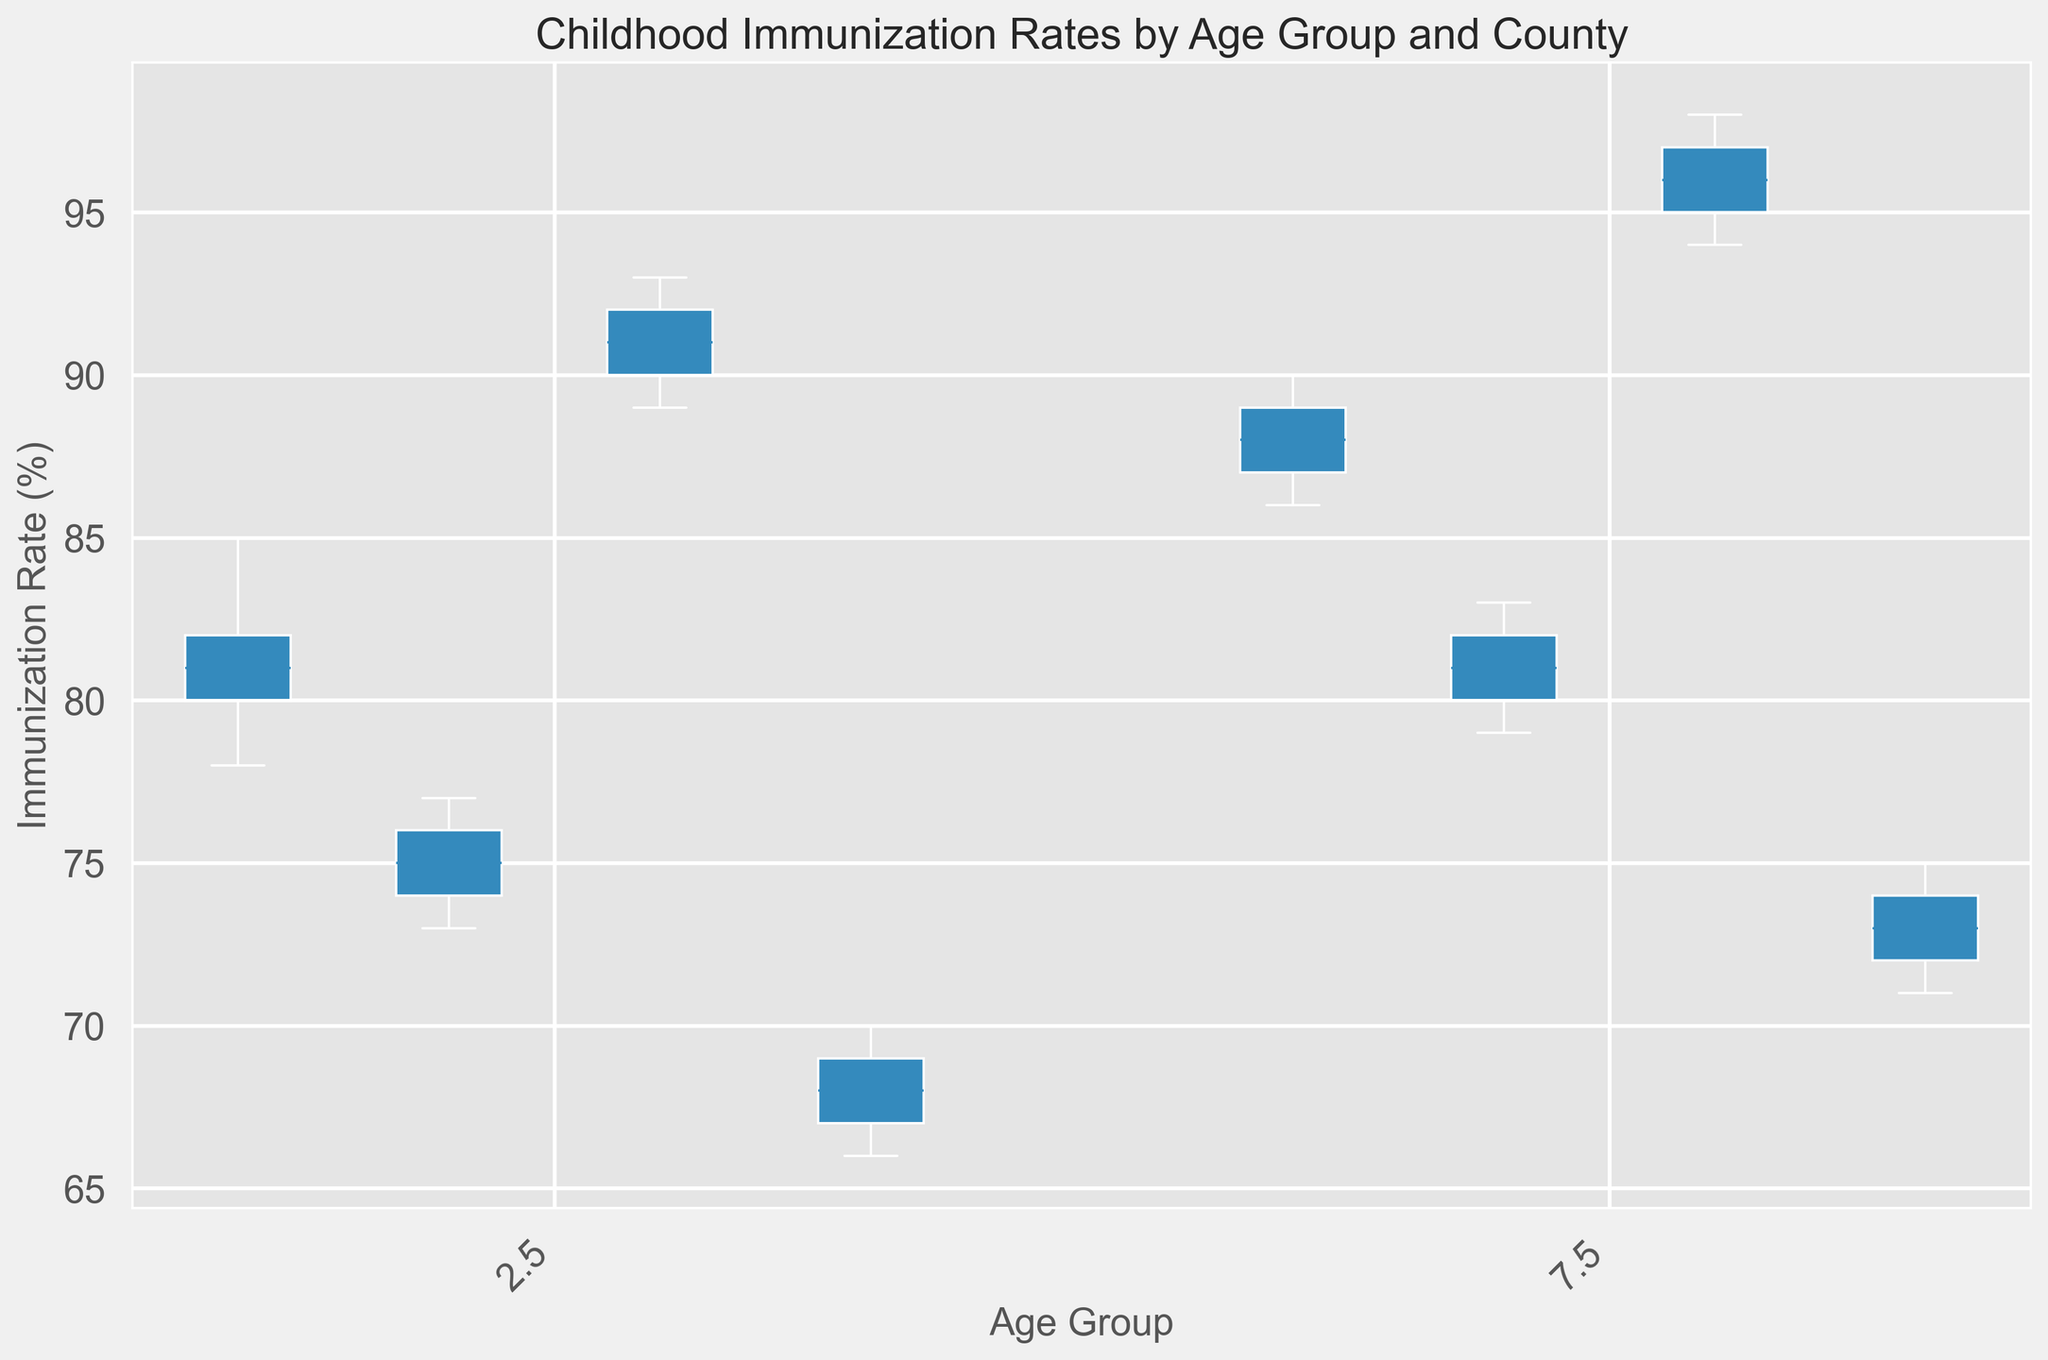Which county has the highest median immunization rate for the 0-1 age group? To find the highest median immunization rate for the 0-1 age group, look at the center lines of the boxplots representing each county. Based on the boxplot, County C has the highest median immunization rate for the 0-1 age group.
Answer: County C Which age group shows greater variability in immunization rates in County A? To determine which age group has greater variability, compare the lengths of the boxes and whiskers for each age group in County A. The 1-2 age group in County A has longer whiskers compared to the other, indicating greater variability.
Answer: 1-2 Is the immunization rate for the 1-2 age group in County D generally lower or higher than the 0-1 age group in County C? To compare these two groups, look at the position of the boxplots. The boxplots for the 1-2 age group in County D are generally positioned lower on the y-axis than those for the 0-1 age group in County C, indicating that the rates are generally lower in County D.
Answer: Lower What is the range of immunization rates for the 0-1 age group in County D? To find the range, look at the bottom and top whiskers of the boxplot for the 0-1 age group in County D. The range is from the lowest value at 66 to the highest value at 70. The range is calculated as 70 - 66.
Answer: 4 Which county has the smallest interquartile range (IQR) for the 1-2 age group? To identify the smallest IQR, compare the lengths of the boxes for each county within the 1-2 age group. The IQR is from Q1 to Q3. County C has the smallest length of the box, indicating the smallest IQR.
Answer: County C Is there a notable outlier in any county within the 0-1 age group? To find outliers, look for any points plotted outside the whiskers of the boxplots for the 0-1 age group. The boxplots do not show any points outside the whiskers, so there are no notable outliers.
Answer: No Are the immunization rates in County B more consistent in the 0-1 or 1-2 age group? Consistency can be determined by looking at the length of the box and whiskers. The 0-1 age group for County B shows shorter whiskers, indicating less variability and more consistency compared to the 1-2 age group.
Answer: 0-1 Which county's 1-2 age group has a median immunization rate closest to 90? To find the median closest to 90, check the center line of the boxplot for each county's 1-2 age group. County A's 1-2 age group has a median very close to 90.
Answer: County A 